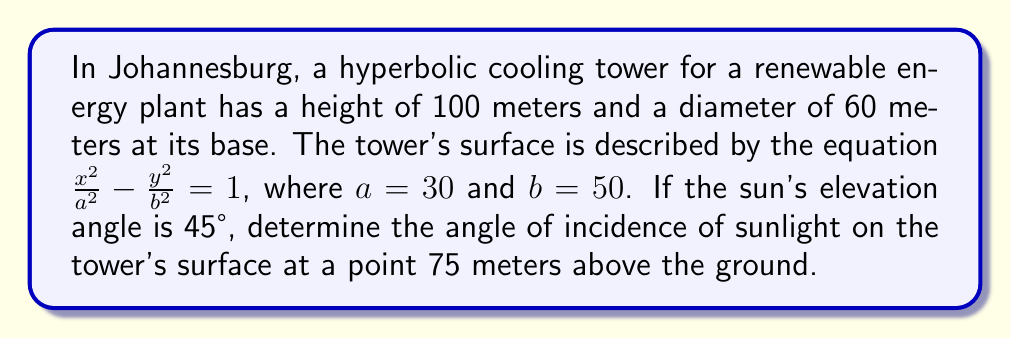Teach me how to tackle this problem. Let's approach this step-by-step:

1) First, we need to find the equation of the hyperbola in the xz-plane:

   $\frac{x^2}{30^2} - \frac{(z-50)^2}{50^2} = 1$

2) To find the slope of the tangent line at the point 75 meters above the ground, we need to differentiate the equation implicitly:

   $\frac{2x}{900} - \frac{2(z-50)}{2500} \cdot \frac{dz}{dx} = 0$

3) Solve for $\frac{dz}{dx}$:

   $\frac{dz}{dx} = \frac{2500x}{900(z-50)}$

4) At 75 meters above the ground, $z = 75$. We need to find the corresponding $x$ value:

   $\frac{x^2}{900} - \frac{25^2}{2500} = 1$
   $x^2 = 900(1 + \frac{625}{2500}) = 1125$
   $x = \sqrt{1125} \approx 33.54$

5) Now we can calculate the slope of the tangent line:

   $\frac{dz}{dx} = \frac{2500(33.54)}{900(25)} \approx 3.71$

6) The angle this tangent line makes with the horizontal is:

   $\theta = \arctan(3.71) \approx 74.89°$

7) The sun's rays make a 45° angle with the horizontal. The angle of incidence is the difference between these angles:

   $74.89° - 45° = 29.89°$
Answer: $29.89°$ 